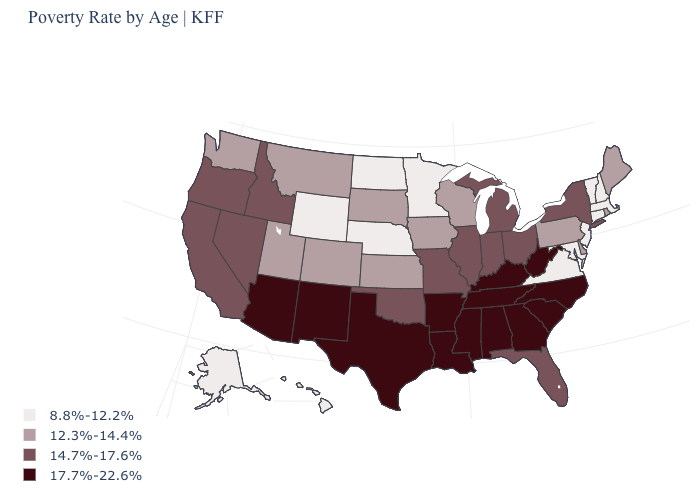Name the states that have a value in the range 8.8%-12.2%?
Answer briefly. Alaska, Connecticut, Hawaii, Maryland, Massachusetts, Minnesota, Nebraska, New Hampshire, New Jersey, North Dakota, Vermont, Virginia, Wyoming. What is the value of West Virginia?
Keep it brief. 17.7%-22.6%. Name the states that have a value in the range 8.8%-12.2%?
Answer briefly. Alaska, Connecticut, Hawaii, Maryland, Massachusetts, Minnesota, Nebraska, New Hampshire, New Jersey, North Dakota, Vermont, Virginia, Wyoming. What is the value of Indiana?
Short answer required. 14.7%-17.6%. Does Massachusetts have the highest value in the Northeast?
Give a very brief answer. No. Name the states that have a value in the range 8.8%-12.2%?
Keep it brief. Alaska, Connecticut, Hawaii, Maryland, Massachusetts, Minnesota, Nebraska, New Hampshire, New Jersey, North Dakota, Vermont, Virginia, Wyoming. What is the highest value in states that border California?
Concise answer only. 17.7%-22.6%. Among the states that border Nevada , which have the lowest value?
Answer briefly. Utah. What is the highest value in the Northeast ?
Quick response, please. 14.7%-17.6%. Which states hav the highest value in the Northeast?
Be succinct. New York. Which states hav the highest value in the West?
Keep it brief. Arizona, New Mexico. What is the value of Minnesota?
Answer briefly. 8.8%-12.2%. What is the lowest value in the South?
Keep it brief. 8.8%-12.2%. Does Rhode Island have a higher value than North Dakota?
Quick response, please. Yes. 